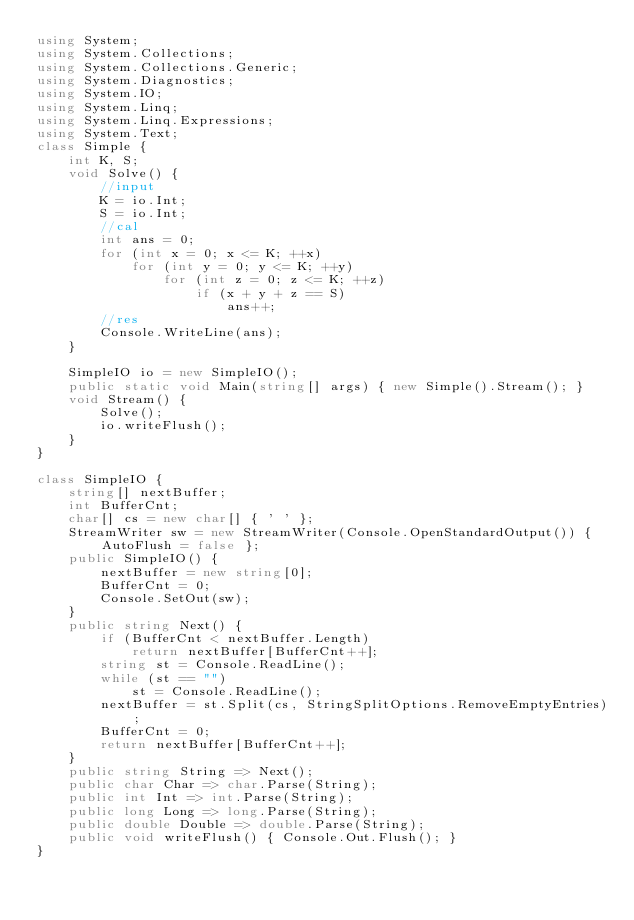Convert code to text. <code><loc_0><loc_0><loc_500><loc_500><_C#_>using System;
using System.Collections;
using System.Collections.Generic;
using System.Diagnostics;
using System.IO;
using System.Linq;
using System.Linq.Expressions;
using System.Text;
class Simple {
    int K, S;
    void Solve() {
        //input
        K = io.Int;
        S = io.Int;
        //cal
        int ans = 0;
        for (int x = 0; x <= K; ++x)
            for (int y = 0; y <= K; ++y)
                for (int z = 0; z <= K; ++z)
                    if (x + y + z == S)
                        ans++;
        //res
        Console.WriteLine(ans);
    }

    SimpleIO io = new SimpleIO();
    public static void Main(string[] args) { new Simple().Stream(); }
    void Stream() {
        Solve();
        io.writeFlush();
    }
}

class SimpleIO {
    string[] nextBuffer;
    int BufferCnt;
    char[] cs = new char[] { ' ' };
    StreamWriter sw = new StreamWriter(Console.OpenStandardOutput()) { AutoFlush = false };
    public SimpleIO() {
        nextBuffer = new string[0];
        BufferCnt = 0;
        Console.SetOut(sw);
    }
    public string Next() {
        if (BufferCnt < nextBuffer.Length)
            return nextBuffer[BufferCnt++];
        string st = Console.ReadLine();
        while (st == "")
            st = Console.ReadLine();
        nextBuffer = st.Split(cs, StringSplitOptions.RemoveEmptyEntries);
        BufferCnt = 0;
        return nextBuffer[BufferCnt++];
    }
    public string String => Next();
    public char Char => char.Parse(String);
    public int Int => int.Parse(String);
    public long Long => long.Parse(String);
    public double Double => double.Parse(String);
    public void writeFlush() { Console.Out.Flush(); }
}
</code> 